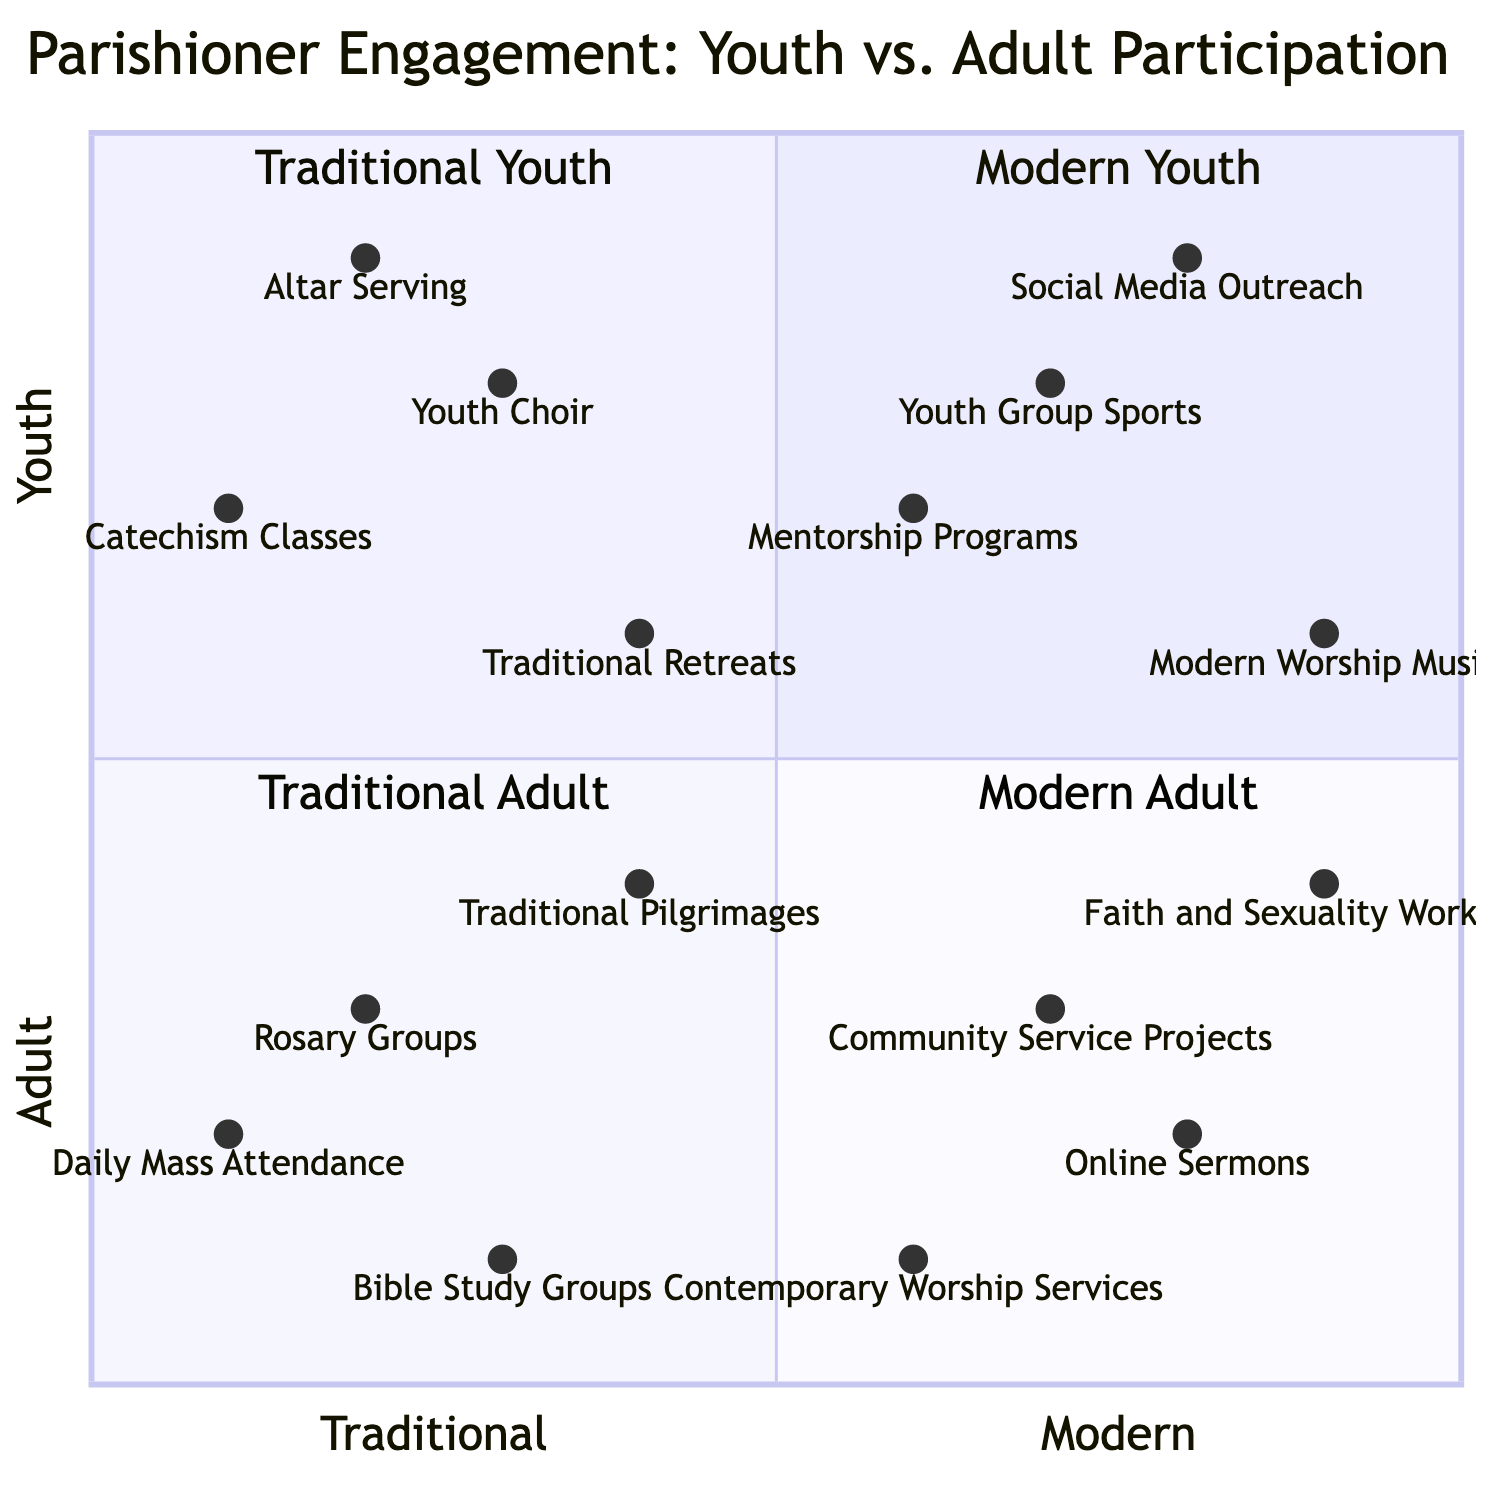What is the most popular activity for Modern Youth? The activity located furthest in the "Modern Youth" quadrant with the highest positioning toward youth engagement is "Social Media Outreach," which is positioned at coordinates [0.8, 0.9].
Answer: Social Media Outreach Which Traditional Adult activity ranks lowest in youth engagement? In the "Traditional Adult" quadrant, "Daily Mass Attendance" has the lowest positioning on the youth engagement axis at [0.1, 0.2].
Answer: Daily Mass Attendance How many activities are categorized under Traditional Youth? By inspecting the list in the "Traditional Youth" quadrant, there are four activities: "Altar Serving," "Youth Choir," "Catechism Classes," and "Traditional Retreats."
Answer: 4 Which activity falls closest to the boundary line between Traditional and Modern preferences? "Traditional Retreats" is positioned at [0.4, 0.6], which is right on the threshold of Traditional and Modern, making it the activity closest to the boundary line.
Answer: Traditional Retreats What is the positioning of Faith and Sexuality Workshops in the diagram? The activity "Faith and Sexuality Workshops" is positioned at coordinates [0.9, 0.4], indicating its place in the "Modern Adult" quadrant, representing a modern adult preference with moderate youth engagement.
Answer: [0.9, 0.4] Which quadrant has the highest level of Adult participation? The quadrant labeled "Modern Adult" contains activities that cater primarily to adults engaging with modern preferences, indicating it has the highest level of Adult participation.
Answer: Modern Adult What is the relationship in engagement between Youth Group Sports and Altar Serving? "Youth Group Sports" has a higher engagement level at [0.7, 0.8] compared to "Altar Serving" at [0.2, 0.9], meaning Youth Group Sports is more modern but less aligned with traditional activities overall.
Answer: Youth Group Sports Which activity represents the lowest engagement in the entire diagram? Among all activities listed across the quadrants, "Catechism Classes," positioned at [0.1, 0.7], has the lowest engagement values while still being moderately youth-oriented.
Answer: Catechism Classes How does the number of Modern Youth activities compare to Traditional Adult activities? There are four activities in both the "Modern Youth" and "Traditional Adult" quadrants; thus, the counts are equal.
Answer: Equal 